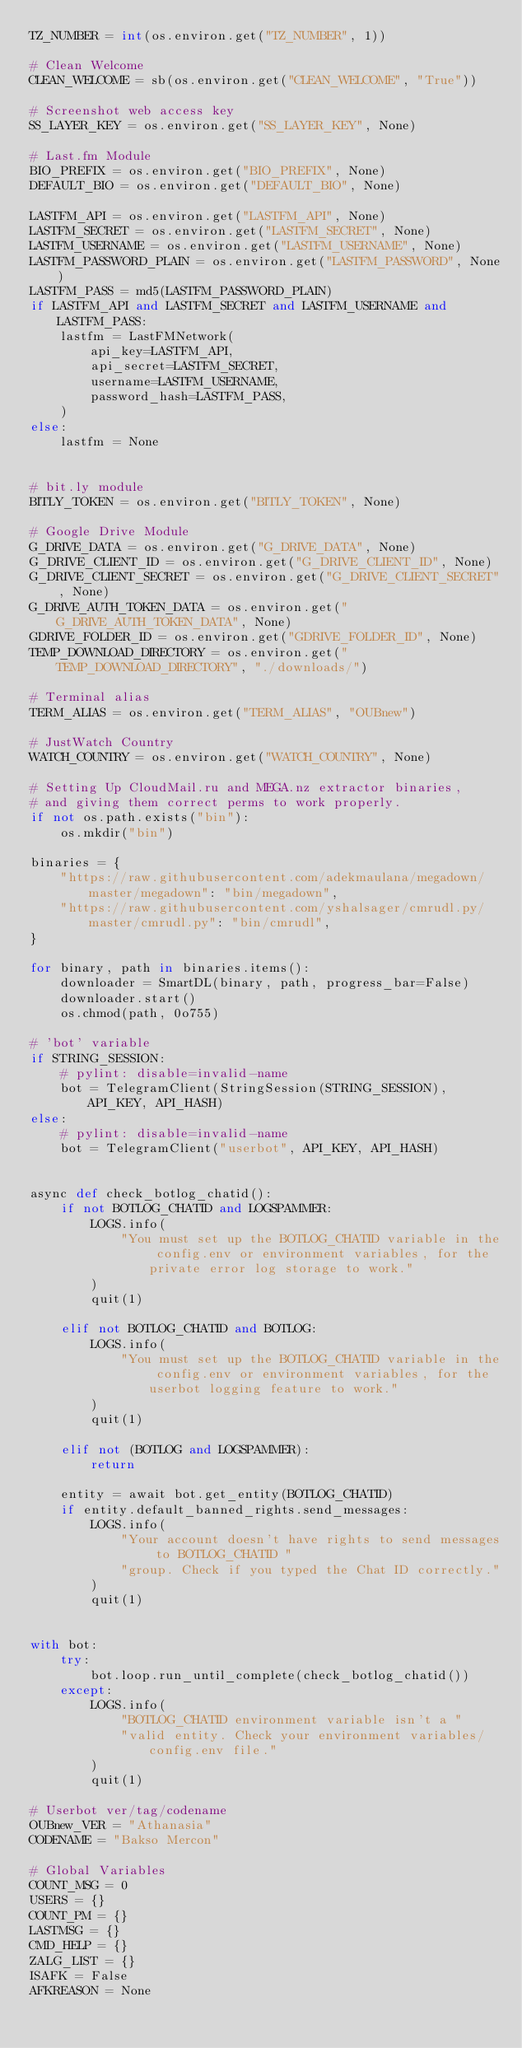<code> <loc_0><loc_0><loc_500><loc_500><_Python_>TZ_NUMBER = int(os.environ.get("TZ_NUMBER", 1))

# Clean Welcome
CLEAN_WELCOME = sb(os.environ.get("CLEAN_WELCOME", "True"))

# Screenshot web access key
SS_LAYER_KEY = os.environ.get("SS_LAYER_KEY", None)

# Last.fm Module
BIO_PREFIX = os.environ.get("BIO_PREFIX", None)
DEFAULT_BIO = os.environ.get("DEFAULT_BIO", None)

LASTFM_API = os.environ.get("LASTFM_API", None)
LASTFM_SECRET = os.environ.get("LASTFM_SECRET", None)
LASTFM_USERNAME = os.environ.get("LASTFM_USERNAME", None)
LASTFM_PASSWORD_PLAIN = os.environ.get("LASTFM_PASSWORD", None)
LASTFM_PASS = md5(LASTFM_PASSWORD_PLAIN)
if LASTFM_API and LASTFM_SECRET and LASTFM_USERNAME and LASTFM_PASS:
    lastfm = LastFMNetwork(
        api_key=LASTFM_API,
        api_secret=LASTFM_SECRET,
        username=LASTFM_USERNAME,
        password_hash=LASTFM_PASS,
    )
else:
    lastfm = None


# bit.ly module
BITLY_TOKEN = os.environ.get("BITLY_TOKEN", None)

# Google Drive Module
G_DRIVE_DATA = os.environ.get("G_DRIVE_DATA", None)
G_DRIVE_CLIENT_ID = os.environ.get("G_DRIVE_CLIENT_ID", None)
G_DRIVE_CLIENT_SECRET = os.environ.get("G_DRIVE_CLIENT_SECRET", None)
G_DRIVE_AUTH_TOKEN_DATA = os.environ.get("G_DRIVE_AUTH_TOKEN_DATA", None)
GDRIVE_FOLDER_ID = os.environ.get("GDRIVE_FOLDER_ID", None)
TEMP_DOWNLOAD_DIRECTORY = os.environ.get("TEMP_DOWNLOAD_DIRECTORY", "./downloads/")

# Terminal alias
TERM_ALIAS = os.environ.get("TERM_ALIAS", "OUBnew")

# JustWatch Country
WATCH_COUNTRY = os.environ.get("WATCH_COUNTRY", None)

# Setting Up CloudMail.ru and MEGA.nz extractor binaries,
# and giving them correct perms to work properly.
if not os.path.exists("bin"):
    os.mkdir("bin")

binaries = {
    "https://raw.githubusercontent.com/adekmaulana/megadown/master/megadown": "bin/megadown",
    "https://raw.githubusercontent.com/yshalsager/cmrudl.py/master/cmrudl.py": "bin/cmrudl",
}

for binary, path in binaries.items():
    downloader = SmartDL(binary, path, progress_bar=False)
    downloader.start()
    os.chmod(path, 0o755)

# 'bot' variable
if STRING_SESSION:
    # pylint: disable=invalid-name
    bot = TelegramClient(StringSession(STRING_SESSION), API_KEY, API_HASH)
else:
    # pylint: disable=invalid-name
    bot = TelegramClient("userbot", API_KEY, API_HASH)


async def check_botlog_chatid():
    if not BOTLOG_CHATID and LOGSPAMMER:
        LOGS.info(
            "You must set up the BOTLOG_CHATID variable in the config.env or environment variables, for the private error log storage to work."
        )
        quit(1)

    elif not BOTLOG_CHATID and BOTLOG:
        LOGS.info(
            "You must set up the BOTLOG_CHATID variable in the config.env or environment variables, for the userbot logging feature to work."
        )
        quit(1)

    elif not (BOTLOG and LOGSPAMMER):
        return

    entity = await bot.get_entity(BOTLOG_CHATID)
    if entity.default_banned_rights.send_messages:
        LOGS.info(
            "Your account doesn't have rights to send messages to BOTLOG_CHATID "
            "group. Check if you typed the Chat ID correctly."
        )
        quit(1)


with bot:
    try:
        bot.loop.run_until_complete(check_botlog_chatid())
    except:
        LOGS.info(
            "BOTLOG_CHATID environment variable isn't a "
            "valid entity. Check your environment variables/config.env file."
        )
        quit(1)

# Userbot ver/tag/codename
OUBnew_VER = "Athanasia"
CODENAME = "Bakso Mercon"

# Global Variables
COUNT_MSG = 0
USERS = {}
COUNT_PM = {}
LASTMSG = {}
CMD_HELP = {}
ZALG_LIST = {}
ISAFK = False
AFKREASON = None
</code> 